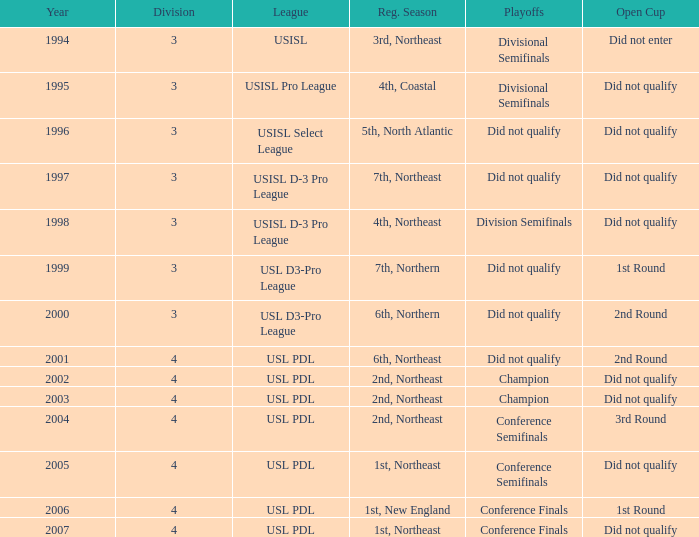Identify the postseason games for usisl select league. Did not qualify. 